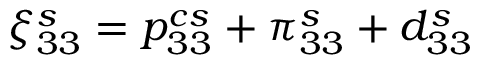<formula> <loc_0><loc_0><loc_500><loc_500>\xi _ { 3 3 } ^ { s } = { p } _ { 3 3 } ^ { c s } + \pi _ { 3 3 } ^ { s } + d _ { 3 3 } ^ { s }</formula> 